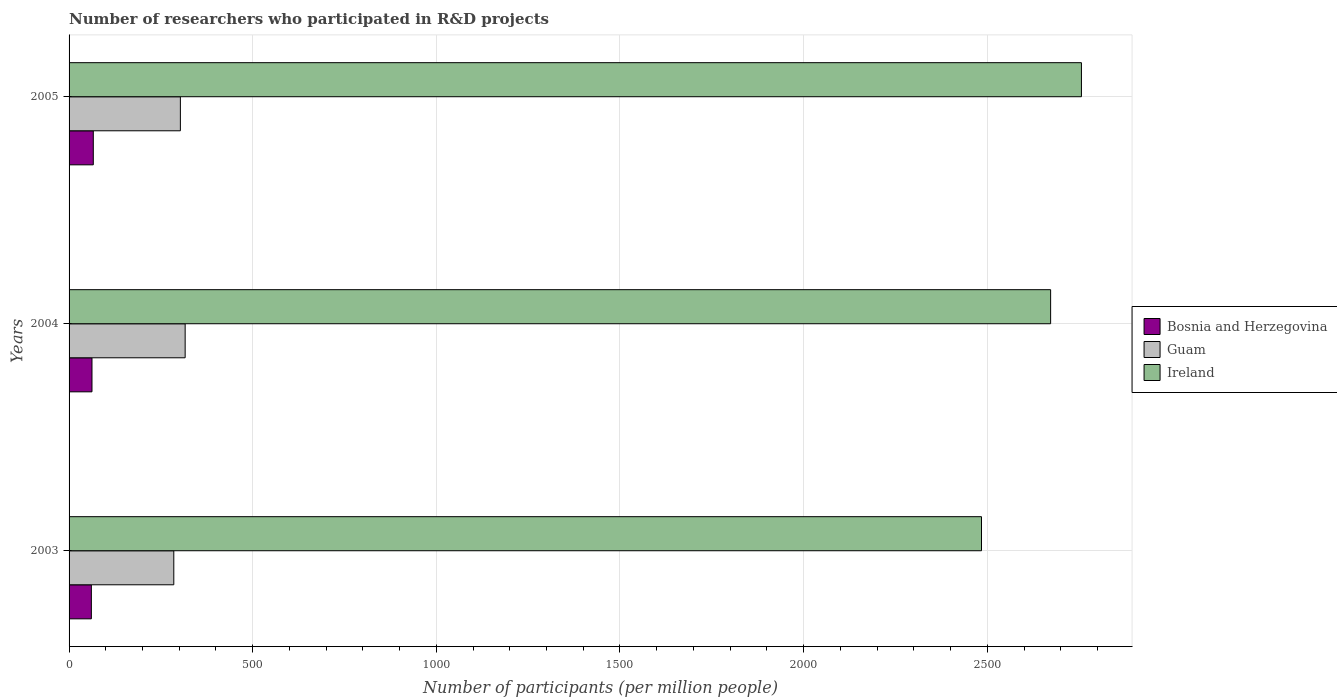How many different coloured bars are there?
Keep it short and to the point. 3. How many groups of bars are there?
Ensure brevity in your answer.  3. Are the number of bars per tick equal to the number of legend labels?
Give a very brief answer. Yes. Are the number of bars on each tick of the Y-axis equal?
Your answer should be compact. Yes. How many bars are there on the 3rd tick from the bottom?
Give a very brief answer. 3. What is the number of researchers who participated in R&D projects in Bosnia and Herzegovina in 2004?
Offer a terse response. 62.41. Across all years, what is the maximum number of researchers who participated in R&D projects in Bosnia and Herzegovina?
Provide a succinct answer. 65.95. Across all years, what is the minimum number of researchers who participated in R&D projects in Bosnia and Herzegovina?
Your response must be concise. 60.7. What is the total number of researchers who participated in R&D projects in Guam in the graph?
Your response must be concise. 904.23. What is the difference between the number of researchers who participated in R&D projects in Guam in 2003 and that in 2004?
Provide a succinct answer. -30.94. What is the difference between the number of researchers who participated in R&D projects in Bosnia and Herzegovina in 2004 and the number of researchers who participated in R&D projects in Guam in 2003?
Offer a terse response. -222.72. What is the average number of researchers who participated in R&D projects in Guam per year?
Keep it short and to the point. 301.41. In the year 2003, what is the difference between the number of researchers who participated in R&D projects in Bosnia and Herzegovina and number of researchers who participated in R&D projects in Ireland?
Ensure brevity in your answer.  -2423.59. What is the ratio of the number of researchers who participated in R&D projects in Guam in 2004 to that in 2005?
Your answer should be very brief. 1.04. Is the number of researchers who participated in R&D projects in Bosnia and Herzegovina in 2004 less than that in 2005?
Provide a succinct answer. Yes. Is the difference between the number of researchers who participated in R&D projects in Bosnia and Herzegovina in 2003 and 2005 greater than the difference between the number of researchers who participated in R&D projects in Ireland in 2003 and 2005?
Ensure brevity in your answer.  Yes. What is the difference between the highest and the second highest number of researchers who participated in R&D projects in Bosnia and Herzegovina?
Offer a very short reply. 3.55. What is the difference between the highest and the lowest number of researchers who participated in R&D projects in Ireland?
Provide a short and direct response. 272.09. Is the sum of the number of researchers who participated in R&D projects in Ireland in 2004 and 2005 greater than the maximum number of researchers who participated in R&D projects in Bosnia and Herzegovina across all years?
Offer a very short reply. Yes. What does the 2nd bar from the top in 2003 represents?
Make the answer very short. Guam. What does the 2nd bar from the bottom in 2004 represents?
Offer a very short reply. Guam. Are all the bars in the graph horizontal?
Make the answer very short. Yes. What is the difference between two consecutive major ticks on the X-axis?
Provide a short and direct response. 500. Does the graph contain grids?
Provide a short and direct response. Yes. How many legend labels are there?
Offer a very short reply. 3. How are the legend labels stacked?
Offer a terse response. Vertical. What is the title of the graph?
Keep it short and to the point. Number of researchers who participated in R&D projects. Does "Lower middle income" appear as one of the legend labels in the graph?
Offer a terse response. No. What is the label or title of the X-axis?
Make the answer very short. Number of participants (per million people). What is the label or title of the Y-axis?
Keep it short and to the point. Years. What is the Number of participants (per million people) in Bosnia and Herzegovina in 2003?
Your answer should be compact. 60.7. What is the Number of participants (per million people) of Guam in 2003?
Make the answer very short. 285.13. What is the Number of participants (per million people) of Ireland in 2003?
Your answer should be compact. 2484.29. What is the Number of participants (per million people) in Bosnia and Herzegovina in 2004?
Provide a short and direct response. 62.41. What is the Number of participants (per million people) in Guam in 2004?
Offer a very short reply. 316.07. What is the Number of participants (per million people) in Ireland in 2004?
Your answer should be compact. 2672.48. What is the Number of participants (per million people) in Bosnia and Herzegovina in 2005?
Offer a very short reply. 65.95. What is the Number of participants (per million people) in Guam in 2005?
Your answer should be compact. 303.03. What is the Number of participants (per million people) in Ireland in 2005?
Provide a short and direct response. 2756.38. Across all years, what is the maximum Number of participants (per million people) in Bosnia and Herzegovina?
Give a very brief answer. 65.95. Across all years, what is the maximum Number of participants (per million people) in Guam?
Give a very brief answer. 316.07. Across all years, what is the maximum Number of participants (per million people) of Ireland?
Ensure brevity in your answer.  2756.38. Across all years, what is the minimum Number of participants (per million people) of Bosnia and Herzegovina?
Provide a succinct answer. 60.7. Across all years, what is the minimum Number of participants (per million people) of Guam?
Offer a very short reply. 285.13. Across all years, what is the minimum Number of participants (per million people) in Ireland?
Give a very brief answer. 2484.29. What is the total Number of participants (per million people) in Bosnia and Herzegovina in the graph?
Give a very brief answer. 189.06. What is the total Number of participants (per million people) in Guam in the graph?
Give a very brief answer. 904.23. What is the total Number of participants (per million people) in Ireland in the graph?
Make the answer very short. 7913.15. What is the difference between the Number of participants (per million people) in Bosnia and Herzegovina in 2003 and that in 2004?
Provide a short and direct response. -1.7. What is the difference between the Number of participants (per million people) in Guam in 2003 and that in 2004?
Ensure brevity in your answer.  -30.94. What is the difference between the Number of participants (per million people) in Ireland in 2003 and that in 2004?
Your answer should be compact. -188.18. What is the difference between the Number of participants (per million people) of Bosnia and Herzegovina in 2003 and that in 2005?
Provide a succinct answer. -5.25. What is the difference between the Number of participants (per million people) in Guam in 2003 and that in 2005?
Keep it short and to the point. -17.9. What is the difference between the Number of participants (per million people) in Ireland in 2003 and that in 2005?
Offer a very short reply. -272.09. What is the difference between the Number of participants (per million people) in Bosnia and Herzegovina in 2004 and that in 2005?
Keep it short and to the point. -3.55. What is the difference between the Number of participants (per million people) of Guam in 2004 and that in 2005?
Make the answer very short. 13.04. What is the difference between the Number of participants (per million people) in Ireland in 2004 and that in 2005?
Provide a short and direct response. -83.9. What is the difference between the Number of participants (per million people) of Bosnia and Herzegovina in 2003 and the Number of participants (per million people) of Guam in 2004?
Your response must be concise. -255.36. What is the difference between the Number of participants (per million people) of Bosnia and Herzegovina in 2003 and the Number of participants (per million people) of Ireland in 2004?
Your answer should be compact. -2611.77. What is the difference between the Number of participants (per million people) of Guam in 2003 and the Number of participants (per million people) of Ireland in 2004?
Provide a short and direct response. -2387.35. What is the difference between the Number of participants (per million people) of Bosnia and Herzegovina in 2003 and the Number of participants (per million people) of Guam in 2005?
Give a very brief answer. -242.32. What is the difference between the Number of participants (per million people) of Bosnia and Herzegovina in 2003 and the Number of participants (per million people) of Ireland in 2005?
Keep it short and to the point. -2695.68. What is the difference between the Number of participants (per million people) of Guam in 2003 and the Number of participants (per million people) of Ireland in 2005?
Keep it short and to the point. -2471.25. What is the difference between the Number of participants (per million people) of Bosnia and Herzegovina in 2004 and the Number of participants (per million people) of Guam in 2005?
Offer a very short reply. -240.62. What is the difference between the Number of participants (per million people) in Bosnia and Herzegovina in 2004 and the Number of participants (per million people) in Ireland in 2005?
Give a very brief answer. -2693.98. What is the difference between the Number of participants (per million people) in Guam in 2004 and the Number of participants (per million people) in Ireland in 2005?
Provide a short and direct response. -2440.31. What is the average Number of participants (per million people) in Bosnia and Herzegovina per year?
Provide a succinct answer. 63.02. What is the average Number of participants (per million people) in Guam per year?
Keep it short and to the point. 301.41. What is the average Number of participants (per million people) of Ireland per year?
Keep it short and to the point. 2637.72. In the year 2003, what is the difference between the Number of participants (per million people) of Bosnia and Herzegovina and Number of participants (per million people) of Guam?
Your response must be concise. -224.43. In the year 2003, what is the difference between the Number of participants (per million people) of Bosnia and Herzegovina and Number of participants (per million people) of Ireland?
Your answer should be very brief. -2423.59. In the year 2003, what is the difference between the Number of participants (per million people) in Guam and Number of participants (per million people) in Ireland?
Keep it short and to the point. -2199.17. In the year 2004, what is the difference between the Number of participants (per million people) in Bosnia and Herzegovina and Number of participants (per million people) in Guam?
Offer a very short reply. -253.66. In the year 2004, what is the difference between the Number of participants (per million people) in Bosnia and Herzegovina and Number of participants (per million people) in Ireland?
Give a very brief answer. -2610.07. In the year 2004, what is the difference between the Number of participants (per million people) in Guam and Number of participants (per million people) in Ireland?
Your answer should be compact. -2356.41. In the year 2005, what is the difference between the Number of participants (per million people) in Bosnia and Herzegovina and Number of participants (per million people) in Guam?
Your answer should be very brief. -237.08. In the year 2005, what is the difference between the Number of participants (per million people) in Bosnia and Herzegovina and Number of participants (per million people) in Ireland?
Ensure brevity in your answer.  -2690.43. In the year 2005, what is the difference between the Number of participants (per million people) in Guam and Number of participants (per million people) in Ireland?
Provide a succinct answer. -2453.35. What is the ratio of the Number of participants (per million people) in Bosnia and Herzegovina in 2003 to that in 2004?
Offer a very short reply. 0.97. What is the ratio of the Number of participants (per million people) of Guam in 2003 to that in 2004?
Ensure brevity in your answer.  0.9. What is the ratio of the Number of participants (per million people) of Ireland in 2003 to that in 2004?
Your answer should be very brief. 0.93. What is the ratio of the Number of participants (per million people) in Bosnia and Herzegovina in 2003 to that in 2005?
Your response must be concise. 0.92. What is the ratio of the Number of participants (per million people) in Guam in 2003 to that in 2005?
Keep it short and to the point. 0.94. What is the ratio of the Number of participants (per million people) in Ireland in 2003 to that in 2005?
Your answer should be very brief. 0.9. What is the ratio of the Number of participants (per million people) of Bosnia and Herzegovina in 2004 to that in 2005?
Ensure brevity in your answer.  0.95. What is the ratio of the Number of participants (per million people) in Guam in 2004 to that in 2005?
Your answer should be very brief. 1.04. What is the ratio of the Number of participants (per million people) in Ireland in 2004 to that in 2005?
Ensure brevity in your answer.  0.97. What is the difference between the highest and the second highest Number of participants (per million people) in Bosnia and Herzegovina?
Your response must be concise. 3.55. What is the difference between the highest and the second highest Number of participants (per million people) in Guam?
Offer a terse response. 13.04. What is the difference between the highest and the second highest Number of participants (per million people) of Ireland?
Keep it short and to the point. 83.9. What is the difference between the highest and the lowest Number of participants (per million people) in Bosnia and Herzegovina?
Your answer should be compact. 5.25. What is the difference between the highest and the lowest Number of participants (per million people) of Guam?
Give a very brief answer. 30.94. What is the difference between the highest and the lowest Number of participants (per million people) of Ireland?
Give a very brief answer. 272.09. 